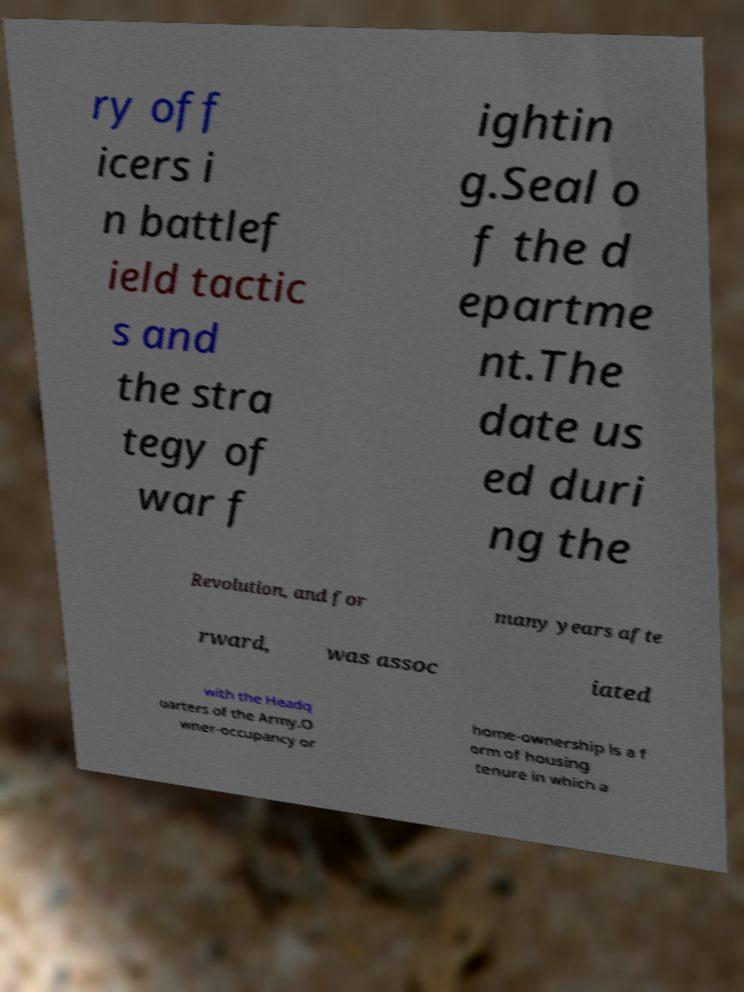There's text embedded in this image that I need extracted. Can you transcribe it verbatim? ry off icers i n battlef ield tactic s and the stra tegy of war f ightin g.Seal o f the d epartme nt.The date us ed duri ng the Revolution, and for many years afte rward, was assoc iated with the Headq uarters of the Army.O wner-occupancy or home-ownership is a f orm of housing tenure in which a 